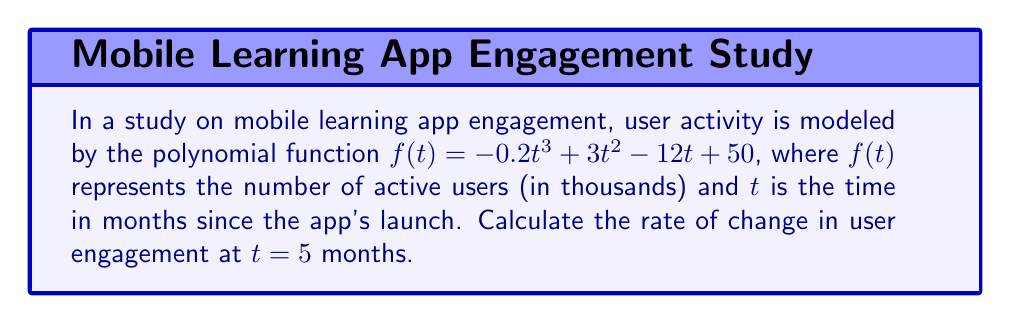Help me with this question. To find the rate of change at a specific point, we need to calculate the derivative of the function and evaluate it at the given point.

Step 1: Find the derivative of $f(t)$
$$f'(t) = \frac{d}{dt}(-0.2t^3 + 3t^2 - 12t + 50)$$
$$f'(t) = -0.6t^2 + 6t - 12$$

Step 2: Evaluate the derivative at $t = 5$
$$f'(5) = -0.6(5)^2 + 6(5) - 12$$
$$f'(5) = -0.6(25) + 30 - 12$$
$$f'(5) = -15 + 30 - 12$$
$$f'(5) = 3$$

The rate of change at $t = 5$ months is 3 thousand users per month.
Answer: 3 thousand users/month 